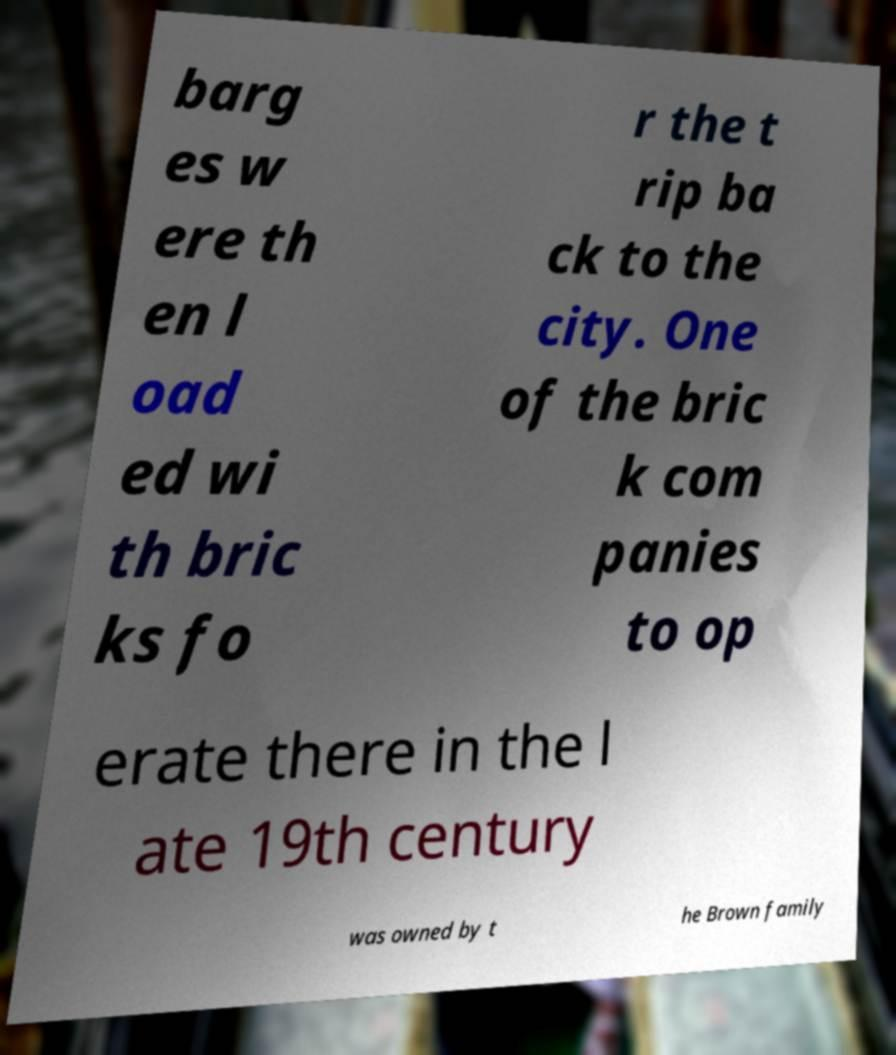Could you assist in decoding the text presented in this image and type it out clearly? barg es w ere th en l oad ed wi th bric ks fo r the t rip ba ck to the city. One of the bric k com panies to op erate there in the l ate 19th century was owned by t he Brown family 